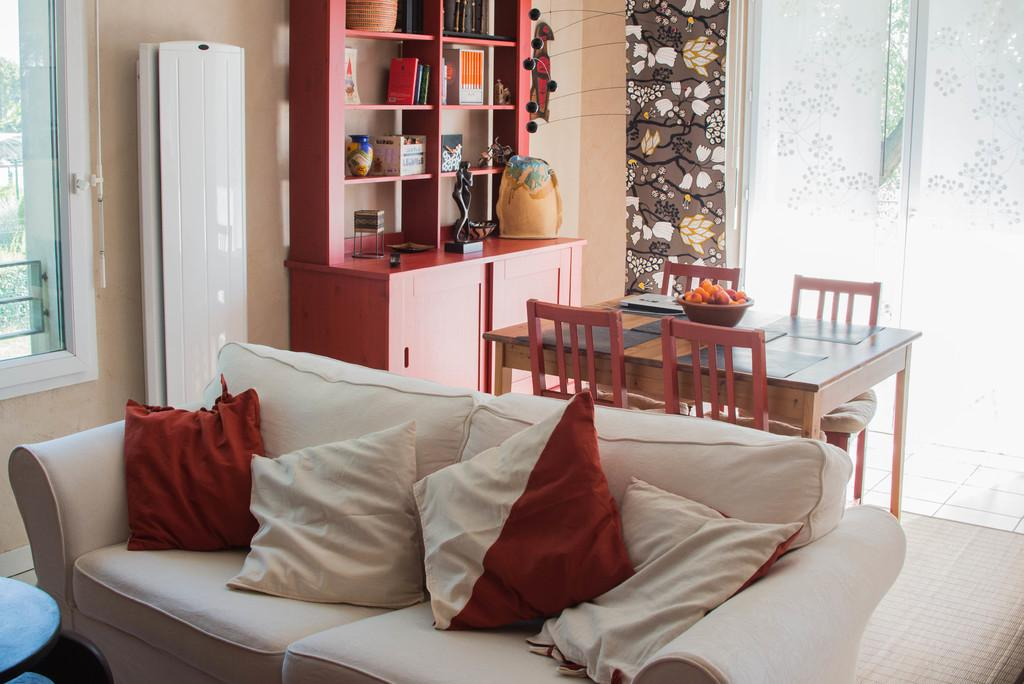What type of furniture is in the image? There is a white sofa in the image. How many pillows are on the sofa? The sofa has four pillows on it. What other piece of furniture can be seen in the image? There is a dining table in the image. Is there any storage furniture in the image? Yes, there is a bookshelf in the image. What substance is being spilled by the sisters in the image? There are no sisters or substance being spilled in the image. 